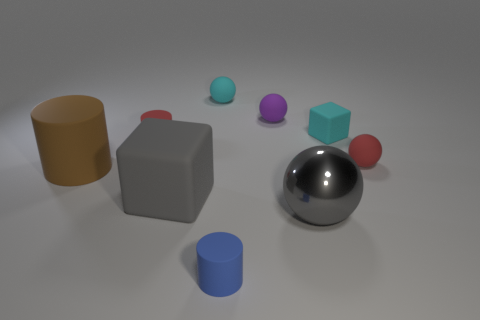Add 1 brown matte cylinders. How many objects exist? 10 Subtract all spheres. How many objects are left? 5 Add 6 red balls. How many red balls are left? 7 Add 5 cyan cylinders. How many cyan cylinders exist? 5 Subtract 0 yellow spheres. How many objects are left? 9 Subtract all yellow matte cylinders. Subtract all large gray balls. How many objects are left? 8 